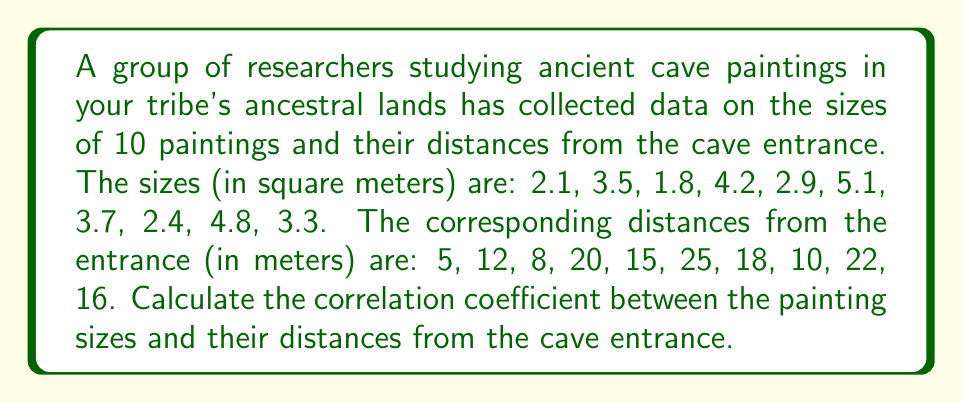Show me your answer to this math problem. To calculate the correlation coefficient, we'll use the Pearson correlation formula:

$$r = \frac{\sum_{i=1}^{n} (x_i - \bar{x})(y_i - \bar{y})}{\sqrt{\sum_{i=1}^{n} (x_i - \bar{x})^2 \sum_{i=1}^{n} (y_i - \bar{y})^2}}$$

Where $x_i$ are the painting sizes and $y_i$ are the distances.

Step 1: Calculate the means
$\bar{x} = \frac{2.1 + 3.5 + 1.8 + 4.2 + 2.9 + 5.1 + 3.7 + 2.4 + 4.8 + 3.3}{10} = 3.38$
$\bar{y} = \frac{5 + 12 + 8 + 20 + 15 + 25 + 18 + 10 + 22 + 16}{10} = 15.1$

Step 2: Calculate $(x_i - \bar{x})$, $(y_i - \bar{y})$, $(x_i - \bar{x})^2$, $(y_i - \bar{y})^2$, and $(x_i - \bar{x})(y_i - \bar{y})$ for each pair

Step 3: Sum the results
$\sum (x_i - \bar{x})(y_i - \bar{y}) = 51.92$
$\sum (x_i - \bar{x})^2 = 11.0776$
$\sum (y_i - \bar{y})^2 = 408.9$

Step 4: Apply the formula
$$r = \frac{51.92}{\sqrt{11.0776 \times 408.9}} = \frac{51.92}{67.3043} = 0.7714$$
Answer: $0.7714$ 